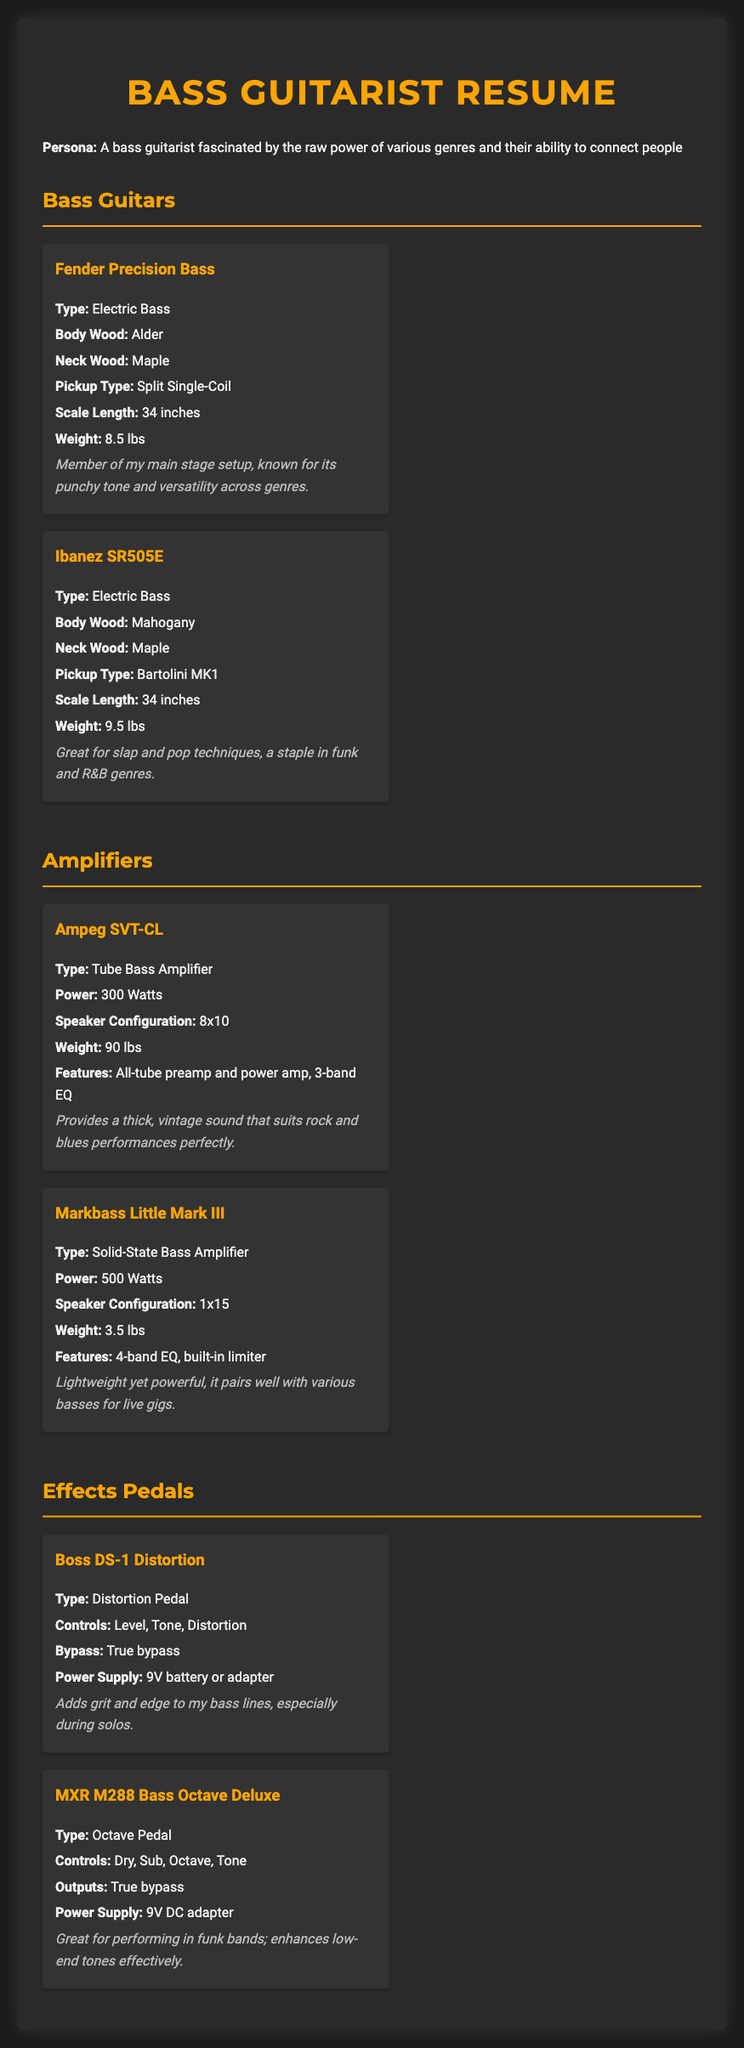What is the weight of the Fender Precision Bass? The weight of the Fender Precision Bass is explicitly stated in the document as 8.5 lbs.
Answer: 8.5 lbs What type of pickup is in the Ibanez SR505E? The document specifies that the Ibanez SR505E uses Bartolini MK1 pickups.
Answer: Bartolini MK1 How much power does the Ampeg SVT-CL amplifier provide? The Ampeg SVT-CL amplifier's power output is listed as 300 Watts.
Answer: 300 Watts Which bass electric is described as a staple in funk and R&B genres? The document notes that the Ibanez SR505E is considered a staple in funk and R&B genres.
Answer: Ibanez SR505E What feature is highlighted in the Markbass Little Mark III amplifier? The document mentions that the Markbass Little Mark III has a built-in limiter as part of its features.
Answer: Built-in limiter Why is the Boss DS-1 Distortion pedal favored by the bassist? The personal preference in the document states that it adds grit and edge to bass lines, particularly during solos.
Answer: Adds grit and edge What type of amplifier is the Markbass Little Mark III? According to the document, the Markbass Little Mark III is a Solid-State Bass Amplifier.
Answer: Solid-State Bass Amplifier What is the body wood of the Fender Precision Bass? The document reveals that the body wood of the Fender Precision Bass is Alder.
Answer: Alder 